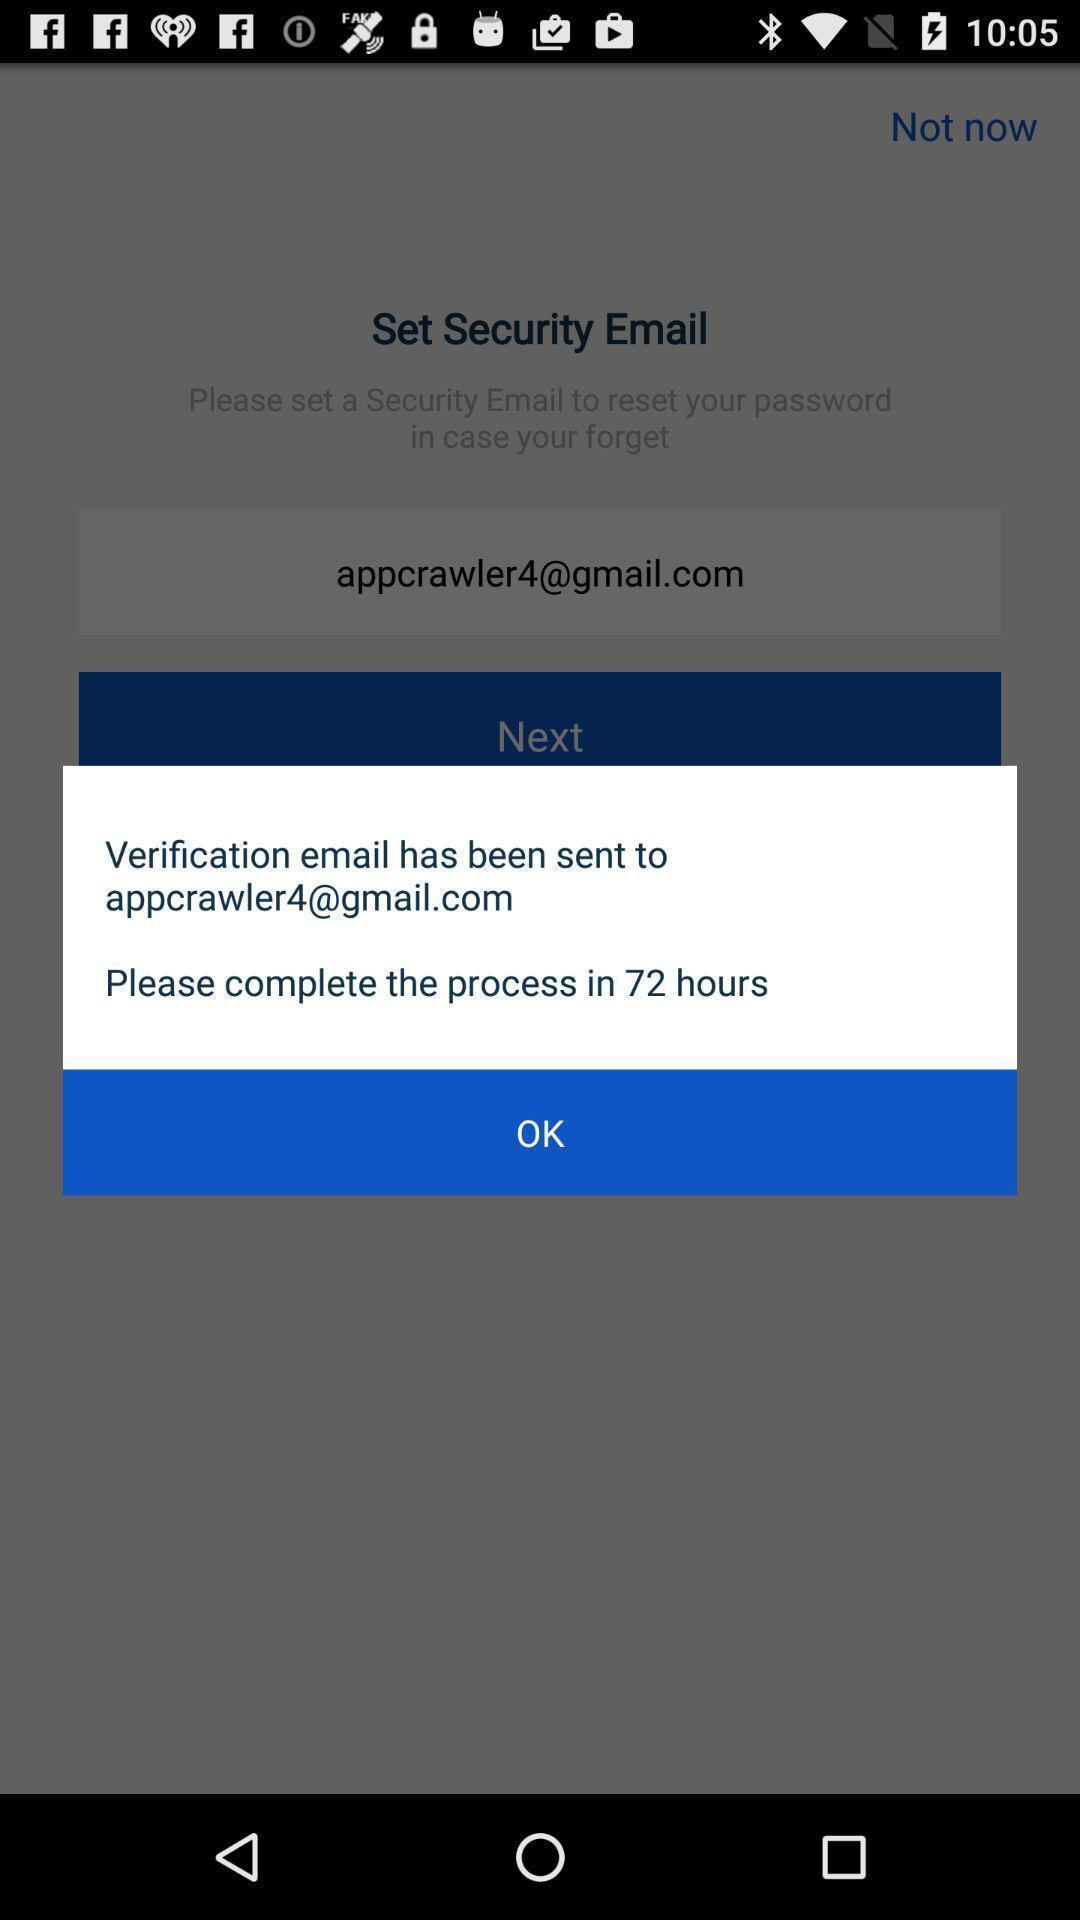Provide a textual representation of this image. Pop-up displaying a message of completing the process. 